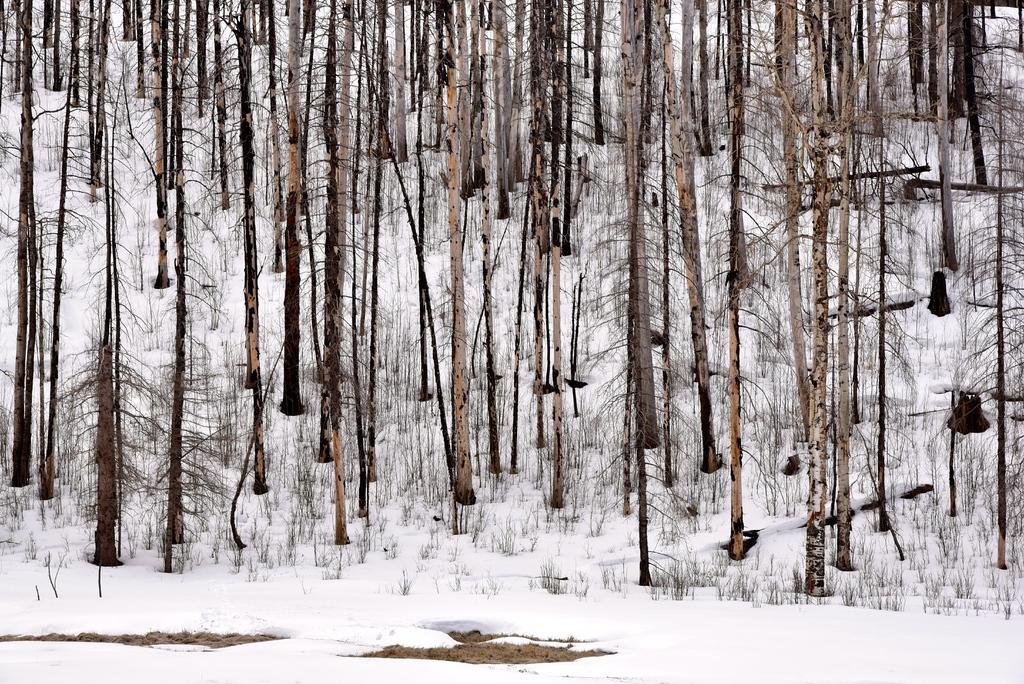What type of vegetation can be seen in the image? There are tree trunks in the image. What type of ground cover is present in the image? There is grass in the image. What is the condition of the land in the image? The land is covered with snow. How many toes can be seen sticking out of the snow in the image? There are no toes visible in the image; it only shows tree trunks, grass, and snow. 